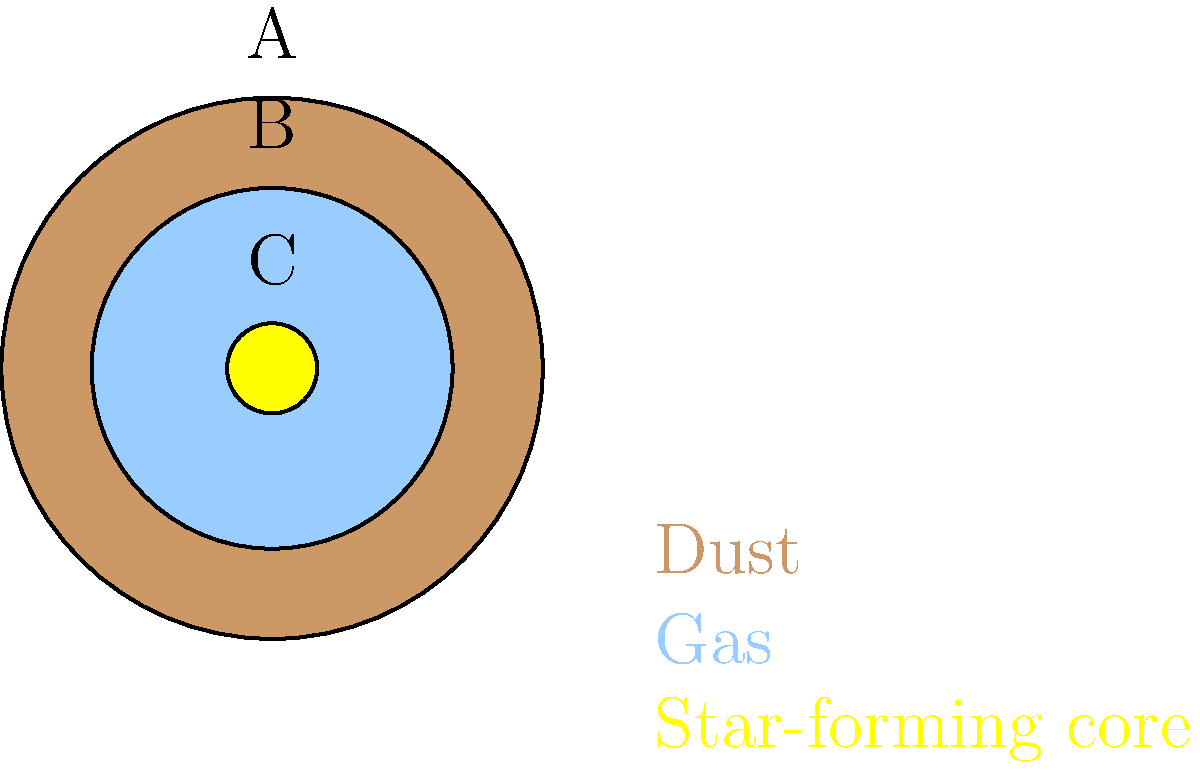In the simplified color-coded illustration of a nebula's structure, which layer (A, B, or C) represents the region where new stars are most likely to form, and why is this significant for long-term investment strategies in the context of pension fund management? To answer this question, let's analyze the structure of the nebula and its implications for long-term investment strategies:

1. Layer A (outermost, brown): This represents the dust layer of the nebula. While important for the overall structure, it's not the primary site of star formation.

2. Layer B (middle, light blue): This represents the gas layer of the nebula. Gas is a crucial component for star formation, but it's not the most dense region.

3. Layer C (innermost, yellow): This represents the star-forming core of the nebula. This is where new stars are most likely to form due to the high density of material and gravitational compression.

The significance of identifying the star-forming region (Layer C) for long-term investment strategies in pension fund management can be explained as follows:

1. Long-term perspective: Star formation is a process that takes millions of years, which aligns with the long-term investment horizon of pension funds.

2. Growth potential: New stars represent new opportunities and growth, similar to emerging markets or innovative technologies in investment portfolios.

3. Risk management: Understanding where the "action" happens in a complex system (like a nebula or financial markets) helps in allocating resources more effectively.

4. Diversification: Just as a nebula has different layers with various roles, a well-managed pension fund should have a diversified portfolio to balance risk and return.

5. Innovation focus: Identifying areas of new growth (like star-forming regions) can guide investments in innovative sectors that may yield higher long-term returns.

6. Sustainability: Star formation ensures the continuation of the galaxy, much like how sustainable investments can ensure the long-term viability of a pension fund.

By understanding this analogy, a pension fund manager can apply similar principles of identifying core growth areas, maintaining a long-term perspective, and balancing risk and innovation in their investment strategy.
Answer: Layer C; it represents core growth areas for long-term, innovative investments. 